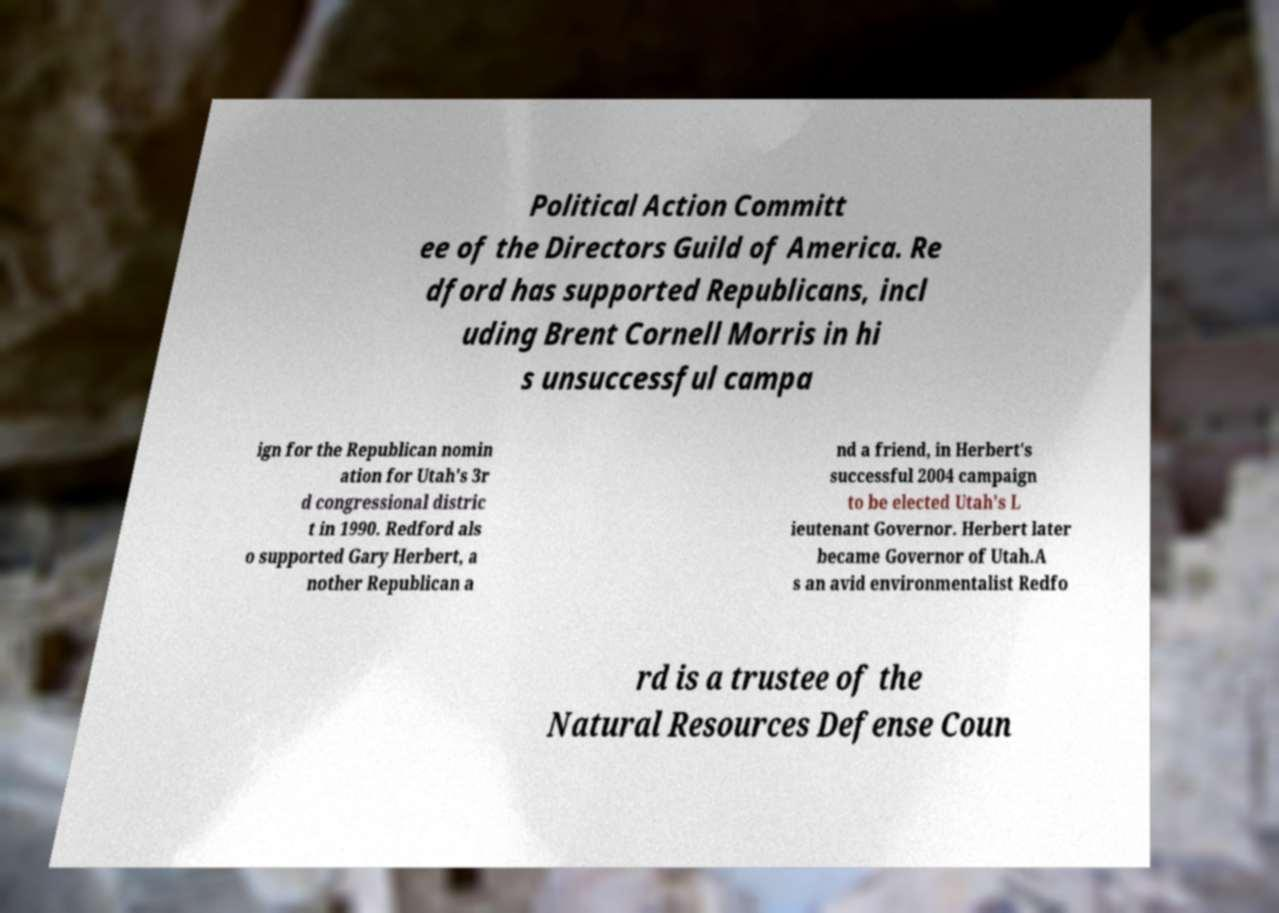What messages or text are displayed in this image? I need them in a readable, typed format. Political Action Committ ee of the Directors Guild of America. Re dford has supported Republicans, incl uding Brent Cornell Morris in hi s unsuccessful campa ign for the Republican nomin ation for Utah's 3r d congressional distric t in 1990. Redford als o supported Gary Herbert, a nother Republican a nd a friend, in Herbert's successful 2004 campaign to be elected Utah's L ieutenant Governor. Herbert later became Governor of Utah.A s an avid environmentalist Redfo rd is a trustee of the Natural Resources Defense Coun 